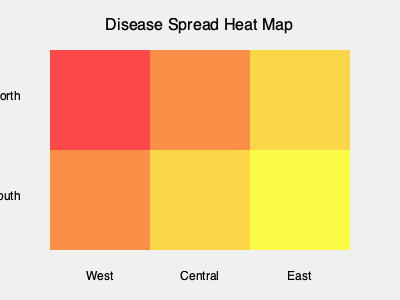Based on the heat map shown, which region appears to have the highest concentration of the disease, and how might this information be used to allocate resources for containment efforts? To answer this question, we need to analyze the heat map and understand its implications:

1. Interpret the color scheme:
   - Red indicates the highest concentration
   - Orange indicates a moderate concentration
   - Yellow indicates a lower concentration

2. Examine the regions:
   - Northwest (top-left) is red, indicating the highest concentration
   - North-central and Northeast are orange, showing moderate concentration
   - Southwest is orange, also indicating moderate concentration
   - South-central and Southeast are yellow, showing lower concentration

3. Identify the region with the highest concentration:
   - The Northwest region (top-left) has the darkest red color, indicating the highest disease concentration

4. Consider resource allocation based on this information:
   - Priority should be given to the Northwest region for containment efforts
   - Secondary focus should be on the orange regions (North-central, Northeast, and Southwest)
   - Resources can be allocated proportionally to the concentration levels
   - Containment strategies may include increased testing, vaccination campaigns, and public health measures in the most affected areas
   - Monitor the yellow regions (South-central and Southeast) for potential spread

5. Recognize the importance of early intervention:
   - Focusing resources on the highest concentration area can help prevent further spread to neighboring regions
   - Early containment in the Northwest may protect the rest of the geographic area from experiencing similar levels of disease prevalence

By using this heat map to guide resource allocation, public health officials can more effectively target their efforts to control the spread of the disease and minimize its impact across the entire region.
Answer: Northwest region; allocate resources proportionally to concentration levels, prioritizing the highest-risk area for containment efforts. 